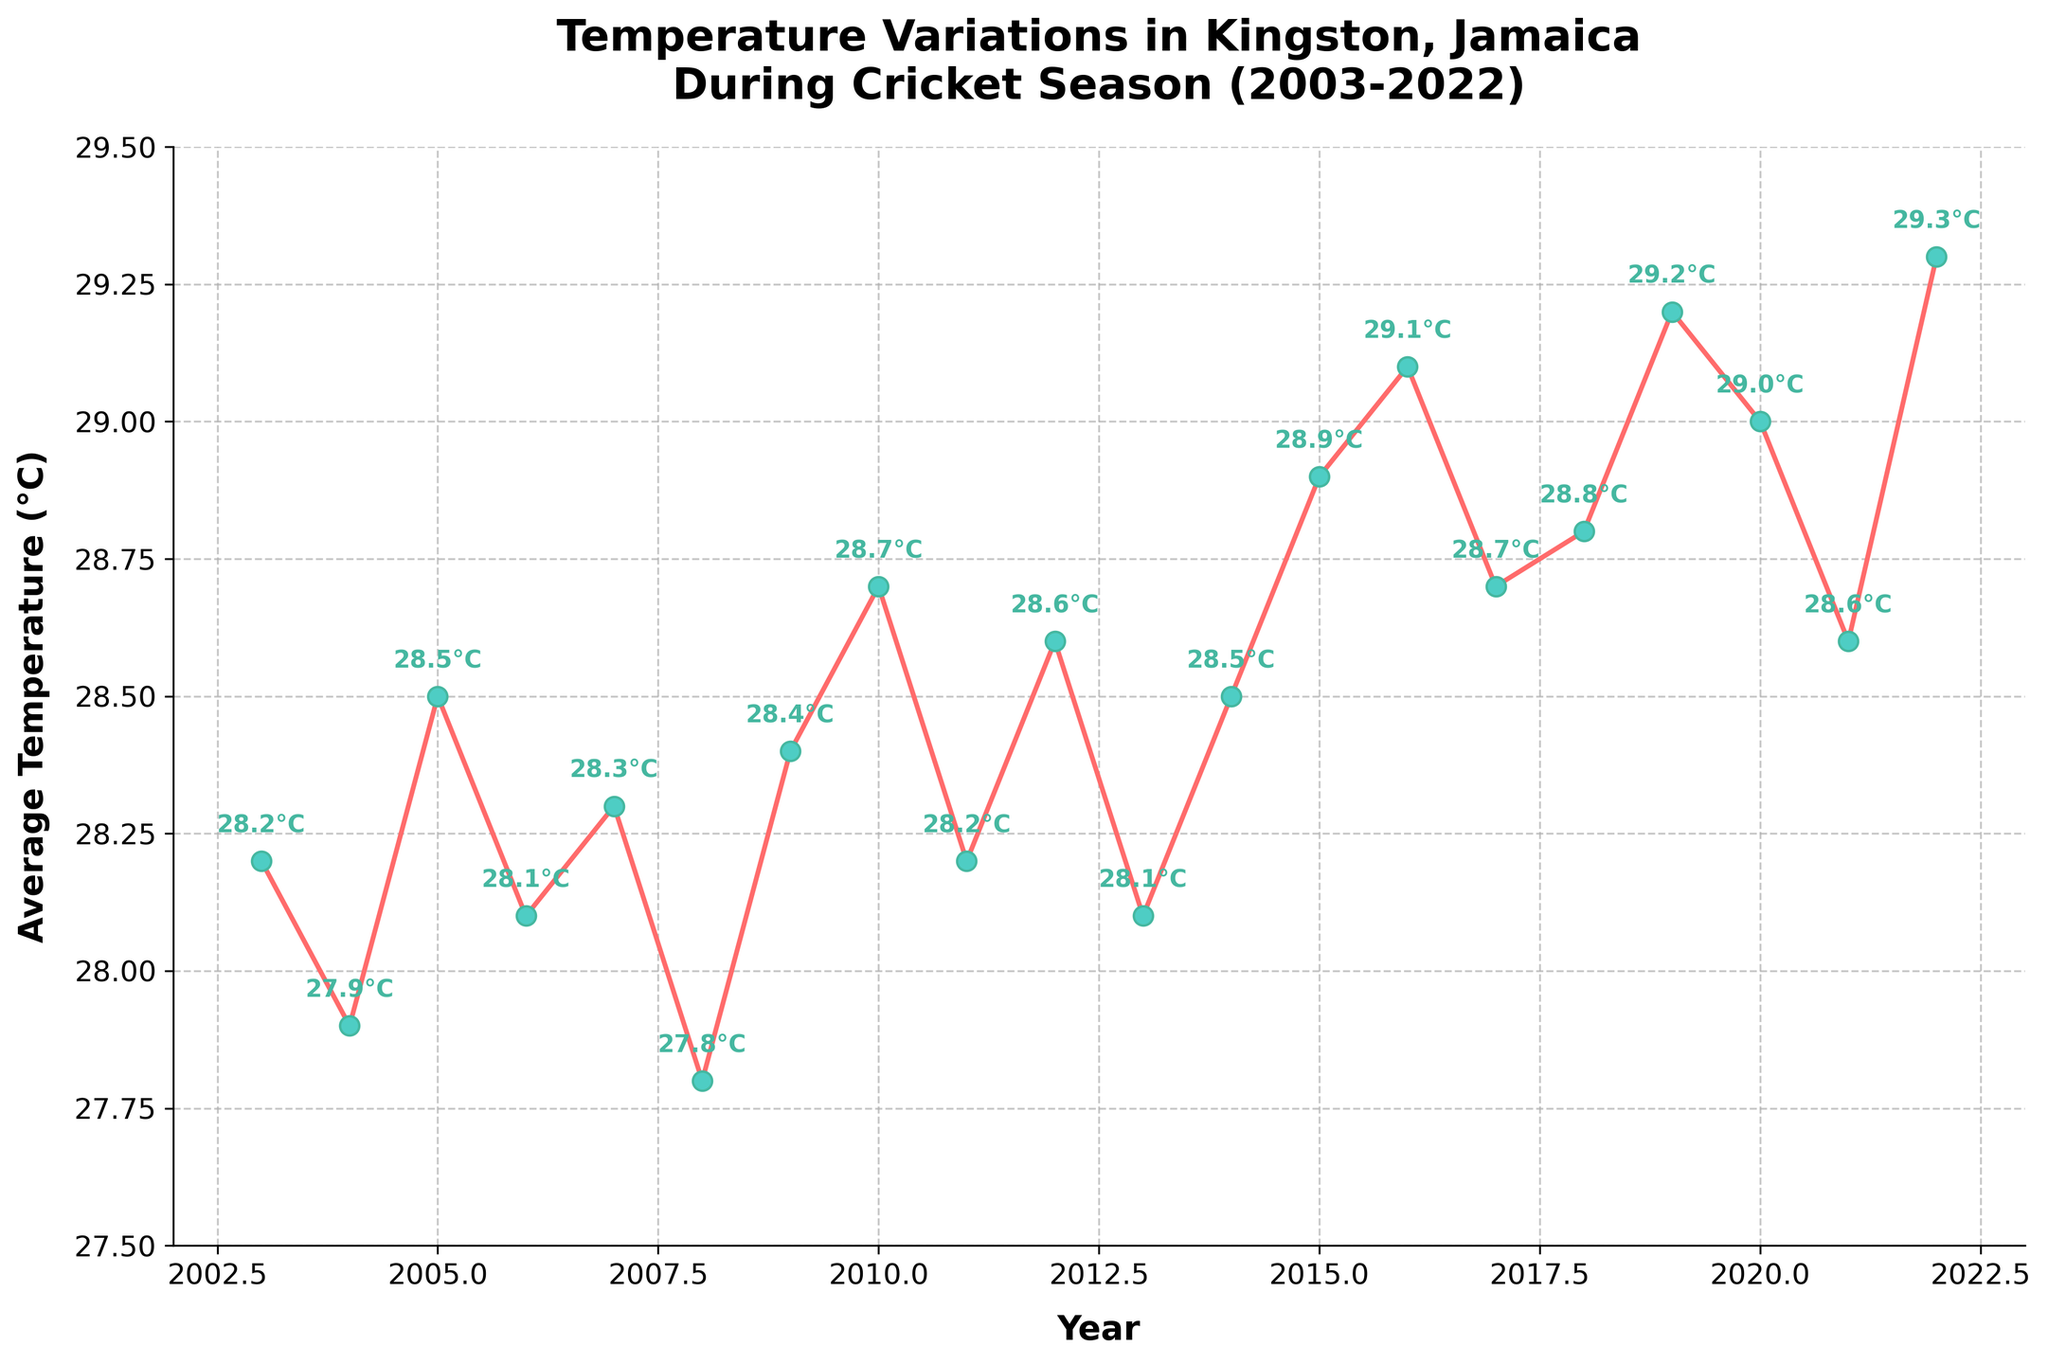What's the average temperature in Kingston during the cricket season in 2021? The average temperature for 2021 can be directly read from the figure.
Answer: 28.6°C Which year had the highest average temperature during the cricket season? To find the year with the highest average temperature, look for the highest point on the plot.
Answer: 2022 Which year had a lower average temperature: 2008 or 2009? Compare the average temperatures for 2008 and 2009 from the plot. 2008 has a temperature of 27.8°C, and 2009 has 28.4°C.
Answer: 2008 What is the trend of the average temperature from 2018 to 2022? Observe the points from 2018 to 2022 on the plot to see if the temperatures are increasing, decreasing, or staying constant. Temperatures are: 2018 - 28.8°C, 2019 - 29.2°C, 2020 - 29.0°C, 2021 - 28.6°C, 2022 - 29.3°C.
Answer: Increasing with some fluctuations What is the difference between the highest and lowest average temperatures recorded over the 20 years? Identify the highest temperature (2022: 29.3°C) and the lowest temperature (2008: 27.8°C). The difference is calculated by subtracting the lowest from the highest.
Answer: 1.5°C What was the average temperature in Kingston in 2010? The average temperature for 2010 based on the plot can be read directly.
Answer: 28.7°C Compare the average temperatures of the years 2003 and 2015. Which year was warmer? Check the temperatures for 2003 (28.2°C) and 2015 (28.9°C) from the plot and compare them.
Answer: 2015 By how much did the average temperature increase from 2011 to 2012? Subtract the 2011 temperature (28.2°C) from the 2012 temperature (28.6°C) to find the increase.
Answer: 0.4°C What is the median temperature from 2003 to 2022? List the temperatures from 2003 to 2022, arrange them in ascending order, and find the middle value or the average of the two middle values. There are 20 data points, so the median is the average of the 10th and 11th points. (28.5°C + 28.6°C) / 2
Answer: 28.545°C What was the temperature in Kingston during the cricket season in 2016? Read the average temperature for 2016 directly from the plot.
Answer: 29.1°C 